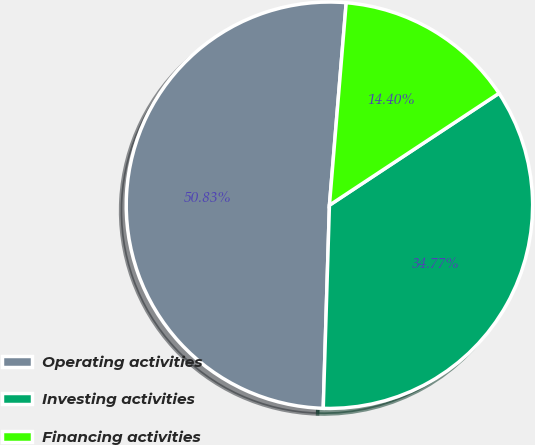Convert chart to OTSL. <chart><loc_0><loc_0><loc_500><loc_500><pie_chart><fcel>Operating activities<fcel>Investing activities<fcel>Financing activities<nl><fcel>50.83%<fcel>34.77%<fcel>14.4%<nl></chart> 